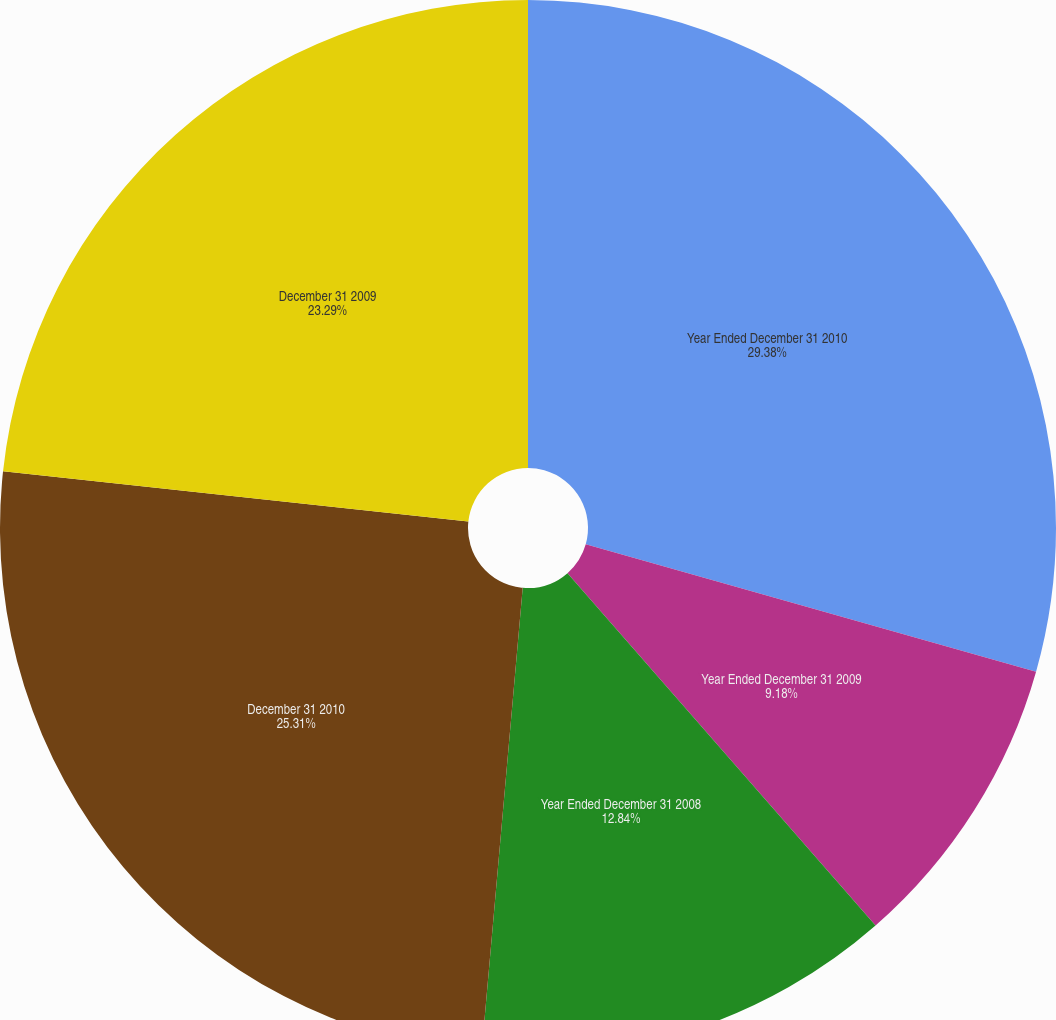Convert chart. <chart><loc_0><loc_0><loc_500><loc_500><pie_chart><fcel>Year Ended December 31 2010<fcel>Year Ended December 31 2009<fcel>Year Ended December 31 2008<fcel>December 31 2010<fcel>December 31 2009<nl><fcel>29.39%<fcel>9.18%<fcel>12.84%<fcel>25.31%<fcel>23.29%<nl></chart> 